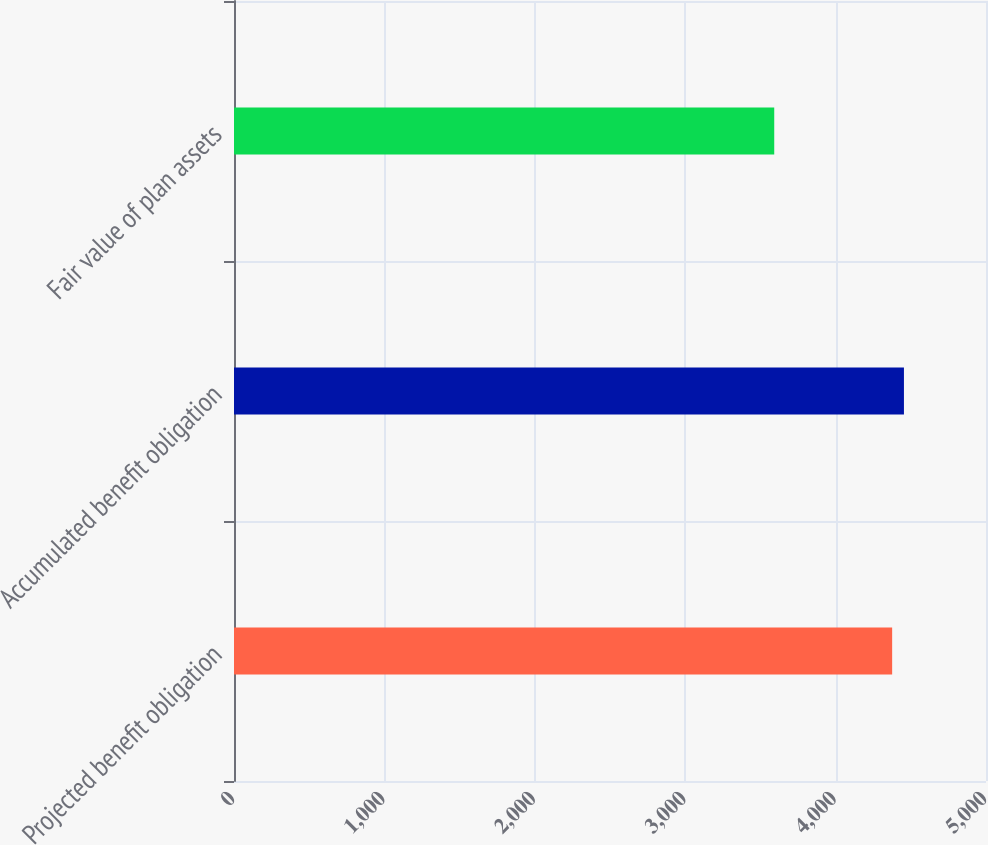Convert chart to OTSL. <chart><loc_0><loc_0><loc_500><loc_500><bar_chart><fcel>Projected benefit obligation<fcel>Accumulated benefit obligation<fcel>Fair value of plan assets<nl><fcel>4376<fcel>4454.4<fcel>3592<nl></chart> 